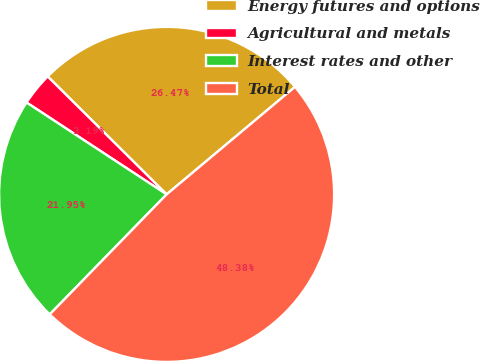Convert chart. <chart><loc_0><loc_0><loc_500><loc_500><pie_chart><fcel>Energy futures and options<fcel>Agricultural and metals<fcel>Interest rates and other<fcel>Total<nl><fcel>26.47%<fcel>3.19%<fcel>21.95%<fcel>48.38%<nl></chart> 